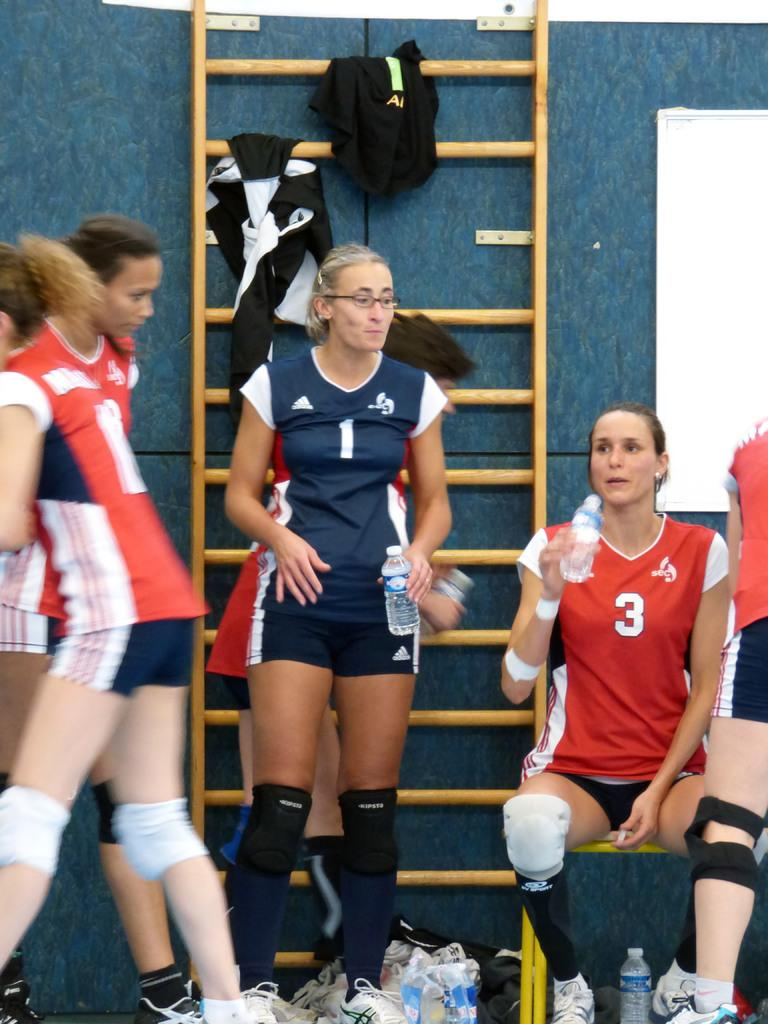Provide a one-sentence caption for the provided image. A group of volleyball players all wearing Addidas gear. 